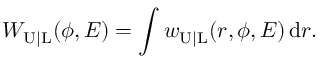Convert formula to latex. <formula><loc_0><loc_0><loc_500><loc_500>W _ { U | L } ( \phi , E ) = \int w _ { U | L } ( r , \phi , E ) \, d r .</formula> 